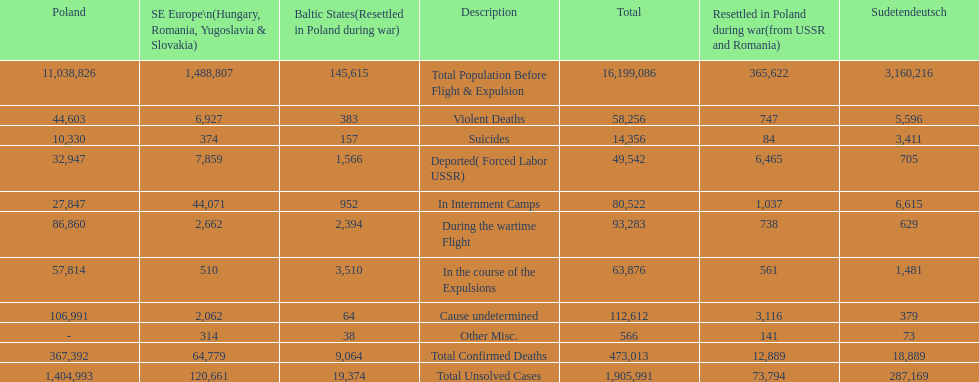Were there more cause undetermined or miscellaneous deaths in the baltic states? Cause undetermined. 